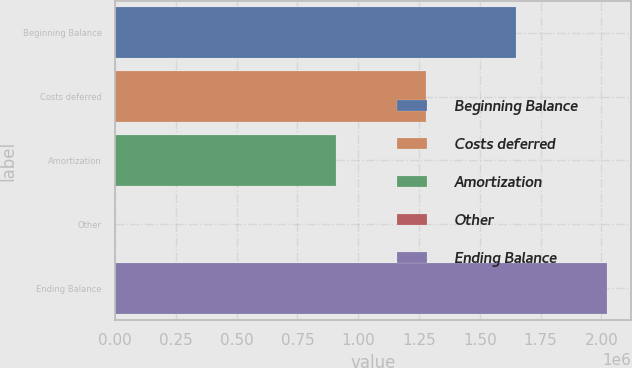Convert chart. <chart><loc_0><loc_0><loc_500><loc_500><bar_chart><fcel>Beginning Balance<fcel>Costs deferred<fcel>Amortization<fcel>Other<fcel>Ending Balance<nl><fcel>1.64765e+06<fcel>1.28057e+06<fcel>907373<fcel>1458<fcel>2.02231e+06<nl></chart> 